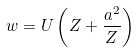Convert formula to latex. <formula><loc_0><loc_0><loc_500><loc_500>w = U \left ( Z + \frac { a ^ { 2 } } Z \right )</formula> 